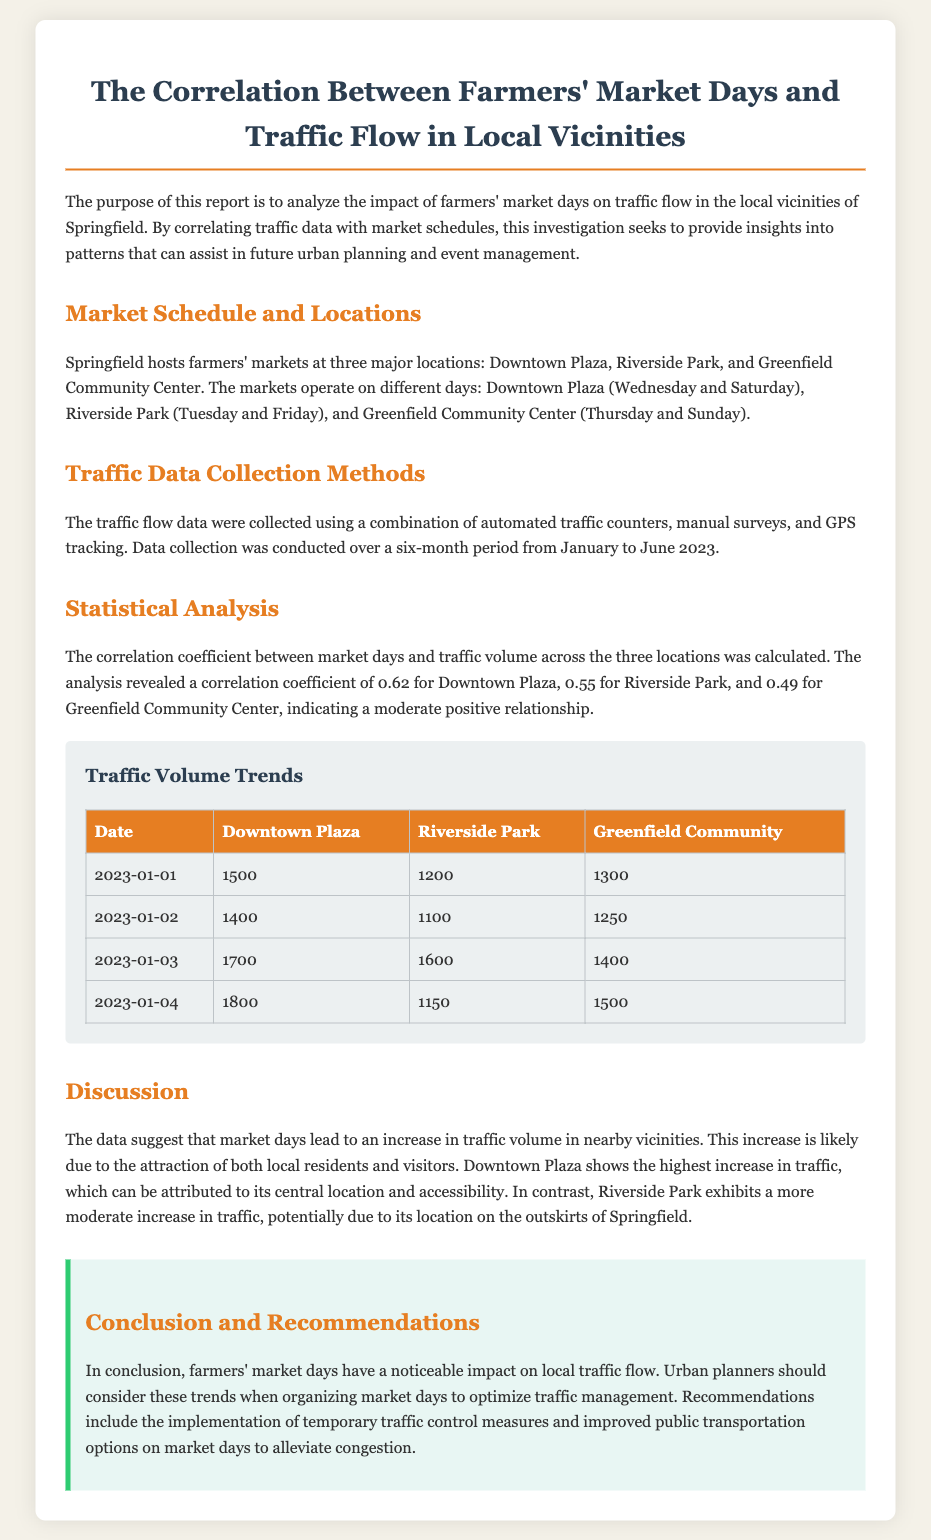What is the title of the report? The title of the report is stated at the beginning of the document and is related to farmers' markets and traffic flow.
Answer: The Correlation Between Farmers' Market Days and Traffic Flow in Local Vicinities How many locations host farmers' markets in Springfield? The document specifies that farmers' markets are hosted at three major locations in Springfield.
Answer: Three What day does Downtown Plaza host its market? The document lists the days on which Downtown Plaza has its market, and Wednesday is included.
Answer: Wednesday What is the correlation coefficient for Riverside Park? The correlation coefficient for Riverside Park is mentioned in the statistical analysis section of the report.
Answer: 0.55 Which location shows the highest traffic increase? The document discusses traffic increase trends and indicates that Downtown Plaza has the highest increase.
Answer: Downtown Plaza What is a recommendation provided in the report? A specific recommendation is made concerning traffic management on market days, as stated in the conclusion section.
Answer: Temporary traffic control measures Which data collection methods were used for traffic data? The document outlines methods used for collecting traffic data and details three approaches taken.
Answer: Automated traffic counters, manual surveys, and GPS tracking What is the purpose of this report? The report outlines its purpose in the introductory paragraph, focusing on analyzing a specific correlation.
Answer: To analyze the impact of farmers' market days on traffic flow in the local vicinities of Springfield 